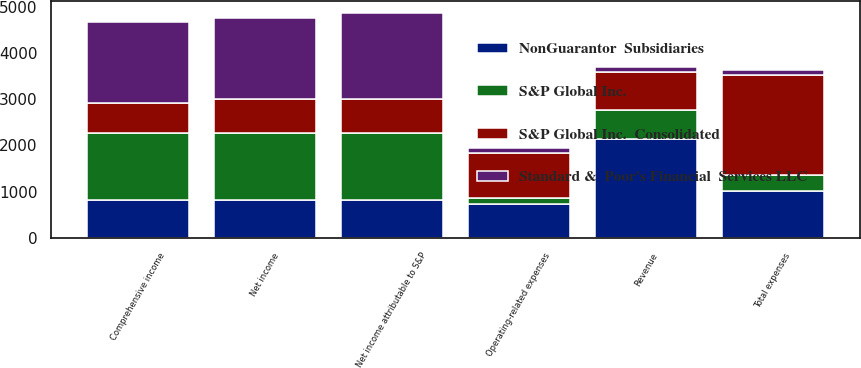Convert chart to OTSL. <chart><loc_0><loc_0><loc_500><loc_500><stacked_bar_chart><ecel><fcel>Revenue<fcel>Operating-related expenses<fcel>Total expenses<fcel>Net income<fcel>Net income attributable to S&P<fcel>Comprehensive income<nl><fcel>S&P Global Inc.<fcel>624<fcel>137<fcel>361<fcel>1449<fcel>1449<fcel>1446<nl><fcel>NonGuarantor  Subsidiaries<fcel>2141<fcel>737<fcel>1009<fcel>824<fcel>824<fcel>822<nl><fcel>S&P Global Inc.  Consolidated<fcel>824<fcel>959<fcel>2152<fcel>740<fcel>740<fcel>655<nl><fcel>Standard &  Poor's Financial  Services LLC<fcel>115<fcel>115<fcel>115<fcel>1745<fcel>1857<fcel>1741<nl></chart> 